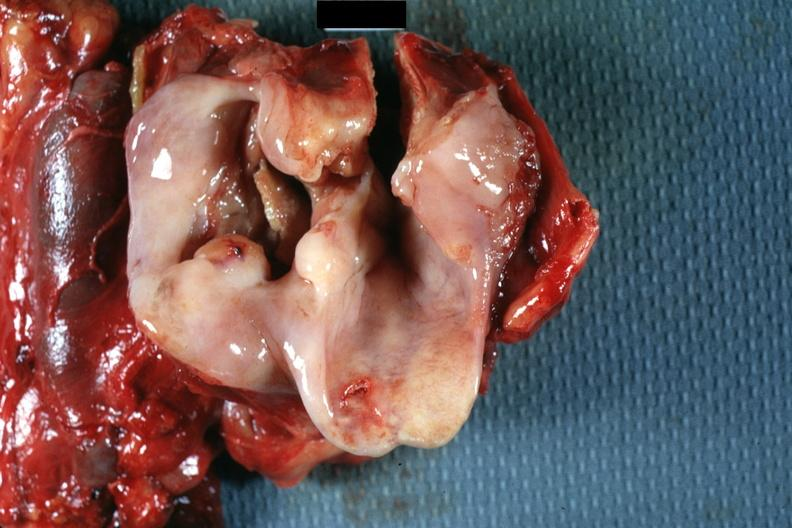s squamous cell carcinoma present?
Answer the question using a single word or phrase. Yes 